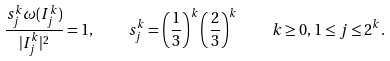Convert formula to latex. <formula><loc_0><loc_0><loc_500><loc_500>\frac { s _ { j } ^ { k } \omega ( I _ { j } ^ { k } ) } { | I _ { j } ^ { k } | ^ { 2 } } = 1 , \quad s _ { j } ^ { k } = \left ( \frac { 1 } { 3 } \right ) ^ { k } \left ( \frac { 2 } { 3 } \right ) ^ { k } \quad k \geq 0 , 1 \leq j \leq 2 ^ { k } .</formula> 